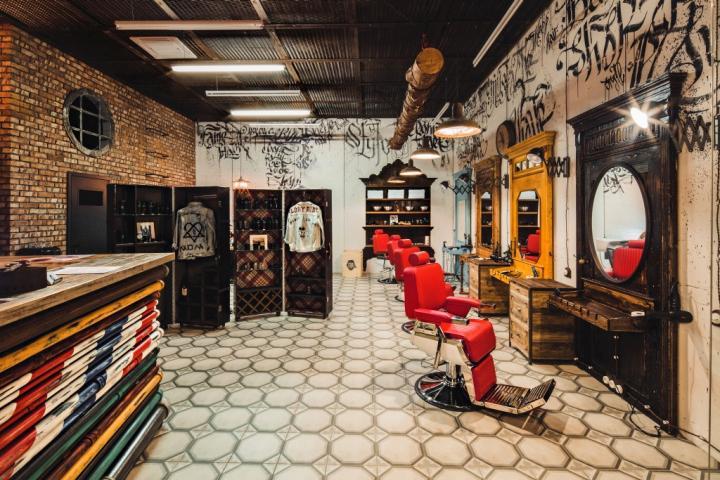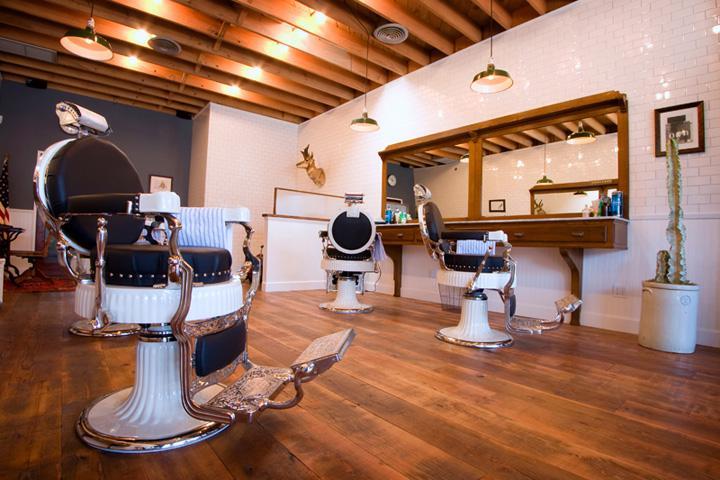The first image is the image on the left, the second image is the image on the right. Evaluate the accuracy of this statement regarding the images: "The chairs on the right side are white and black.". Is it true? Answer yes or no. Yes. 